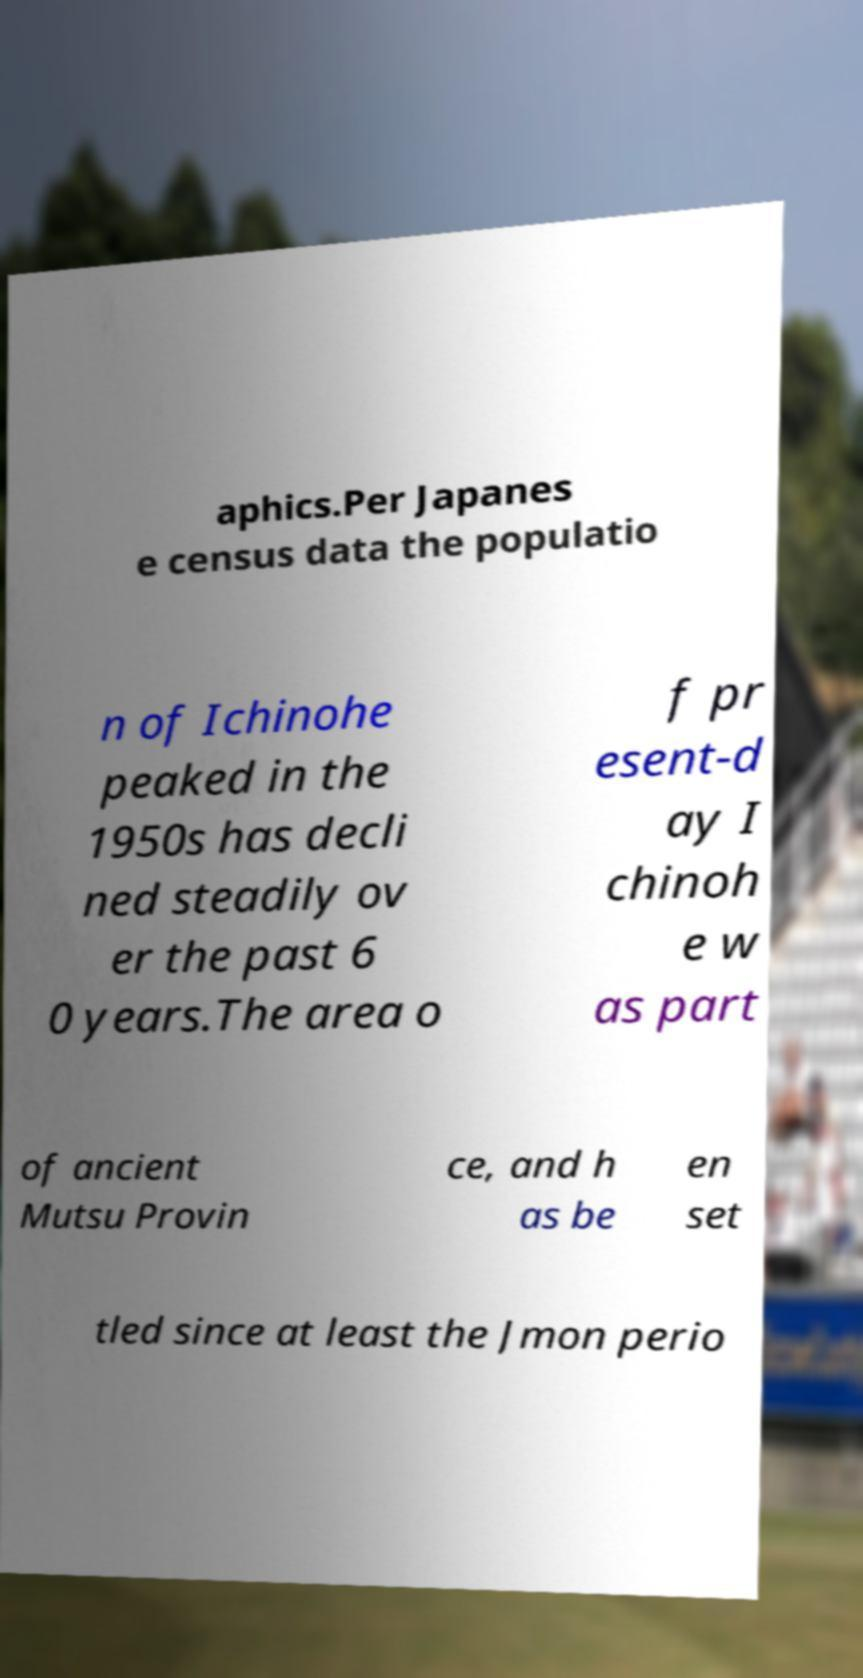Please identify and transcribe the text found in this image. aphics.Per Japanes e census data the populatio n of Ichinohe peaked in the 1950s has decli ned steadily ov er the past 6 0 years.The area o f pr esent-d ay I chinoh e w as part of ancient Mutsu Provin ce, and h as be en set tled since at least the Jmon perio 